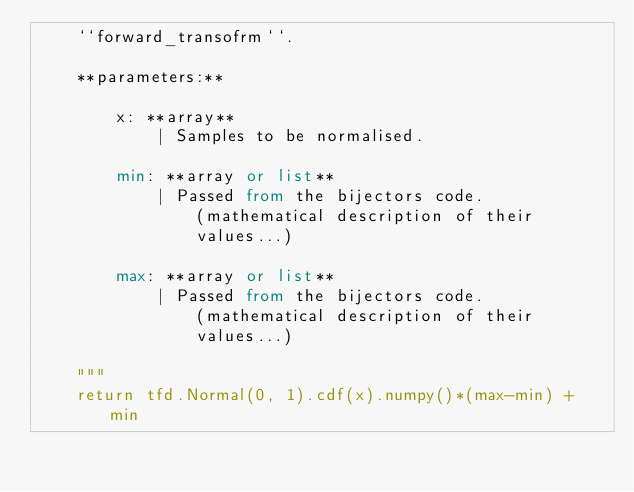Convert code to text. <code><loc_0><loc_0><loc_500><loc_500><_Python_>    ``forward_transofrm``.

    **parameters:**

        x: **array**
            | Samples to be normalised.

        min: **array or list**
            | Passed from the bijectors code.
                (mathematical description of their
                values...)

        max: **array or list**
            | Passed from the bijectors code.
                (mathematical description of their
                values...)

    """
    return tfd.Normal(0, 1).cdf(x).numpy()*(max-min) + min
</code> 